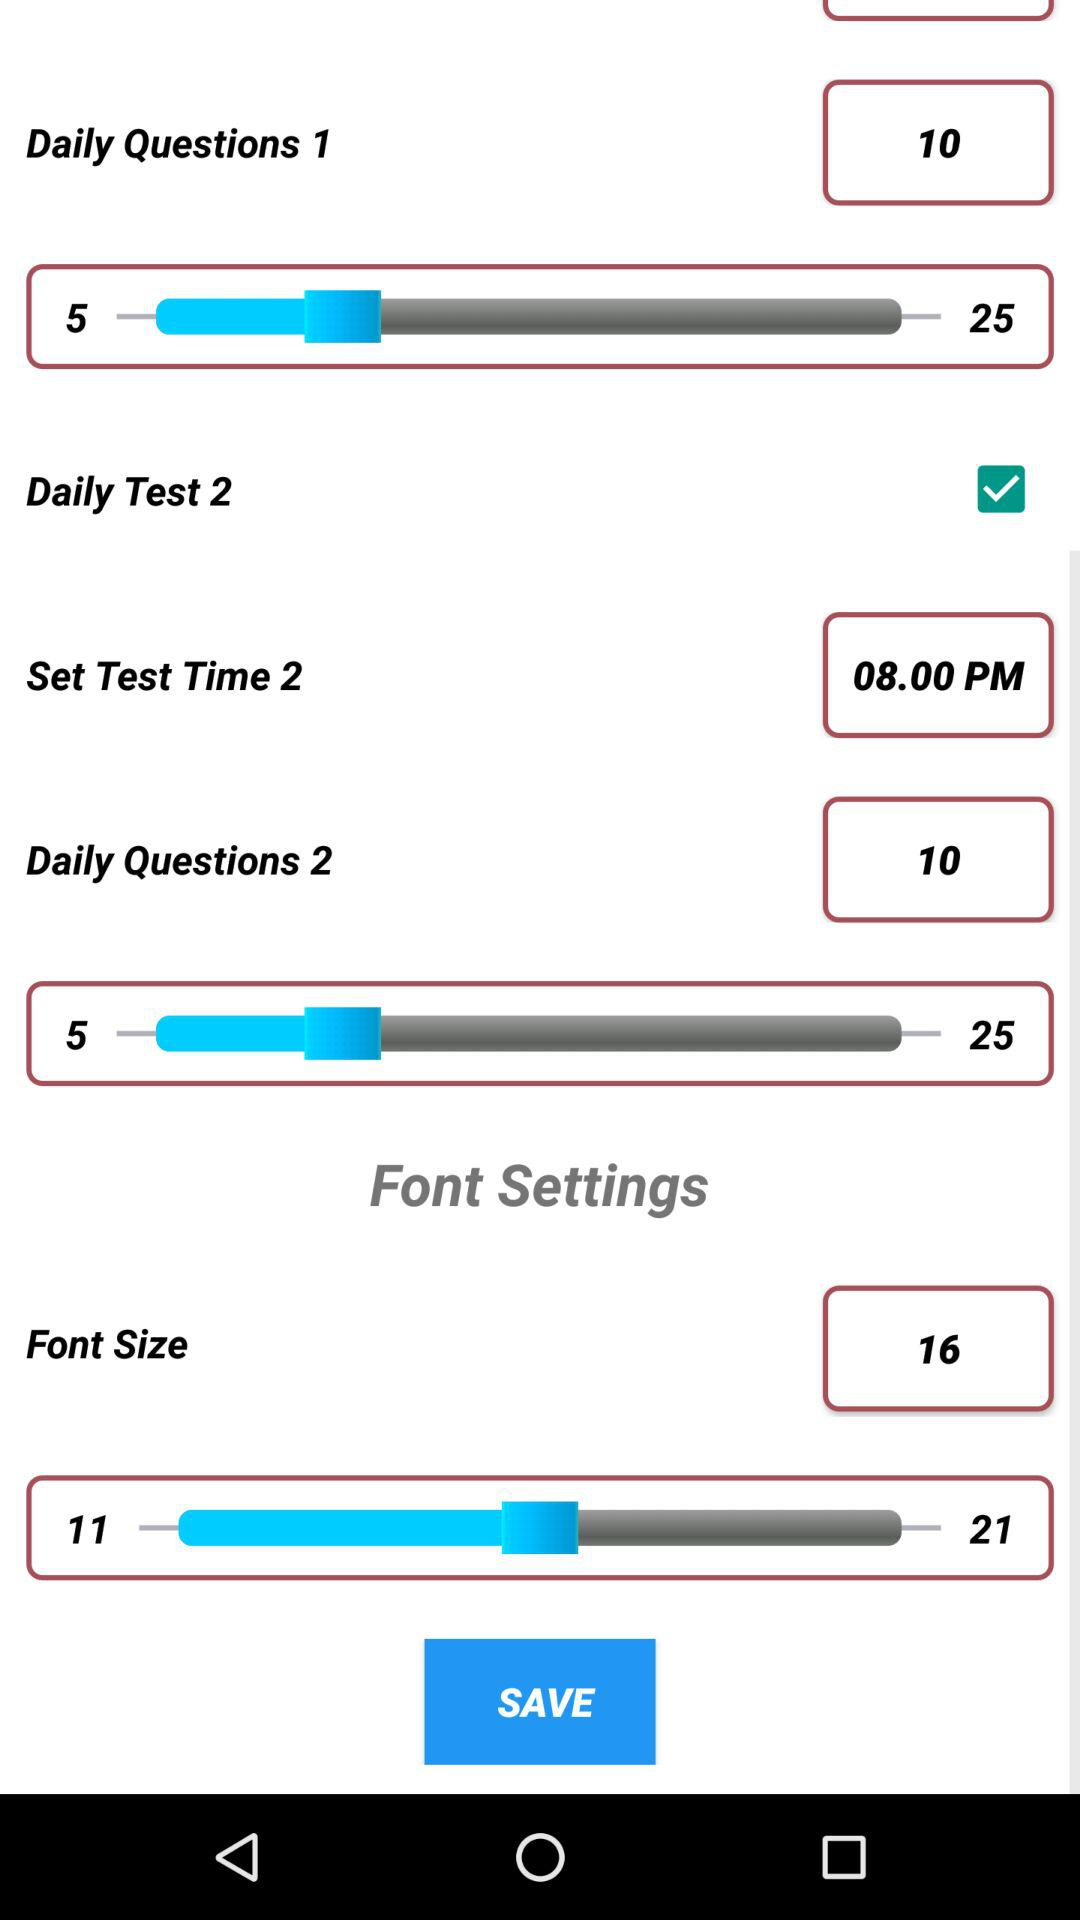What is the selected number of questions for "Daily Questions 1"? The selected number of questions for "Daily Questions 1" is 10. 